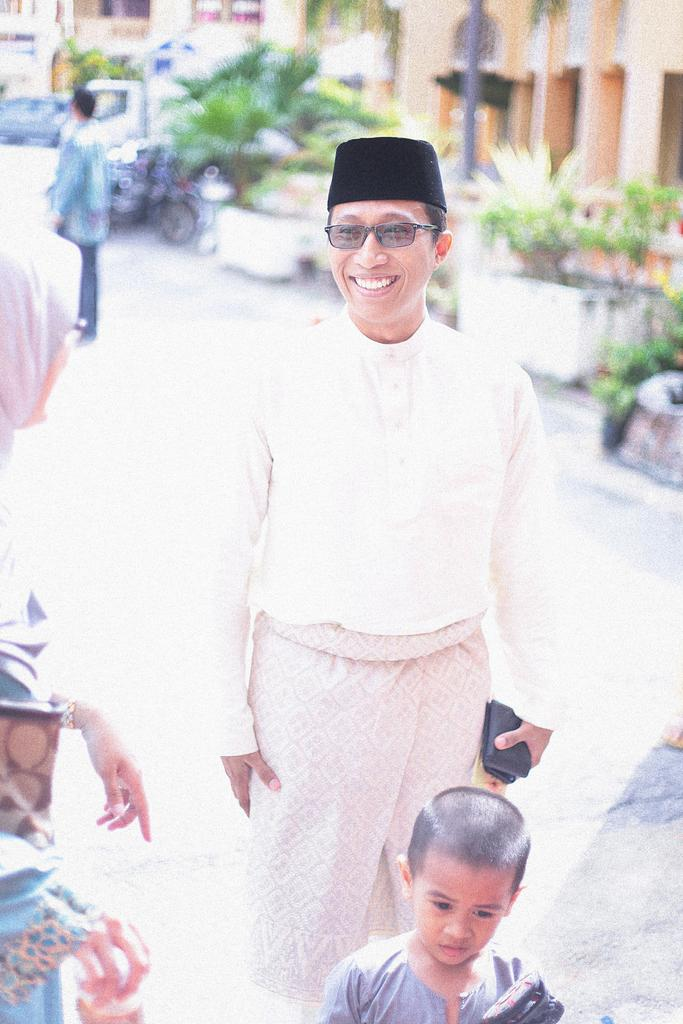How many people are in the image? There are people in the image, including a kid. Can you describe the attire of any person in the image? Yes, a person in the image is wearing goggles, and another person is wearing a hat. What is a person in the image holding? A person in the image is holding an object. What can be seen in the background of the image? The background of the image is blurred, but there are buildings, vehicles, at least one person, a pole, and plants visible. What type of linen is draped over the pole in the image? There is no linen present in the image, and no such object is draped over the pole. How much salt is visible on the vehicles in the image? There is no salt visible on the vehicles in the image. 